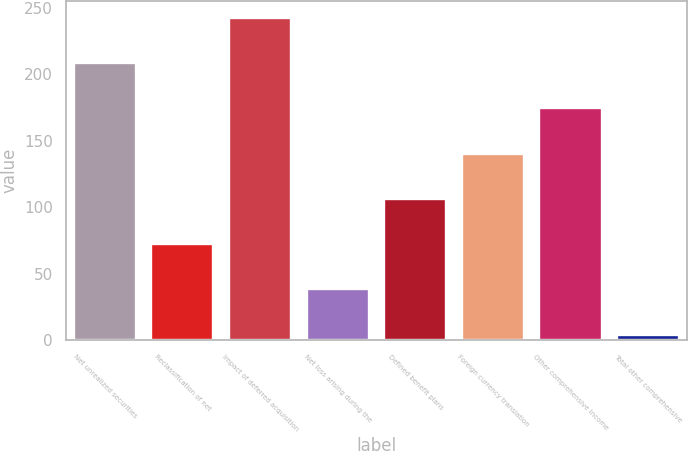Convert chart. <chart><loc_0><loc_0><loc_500><loc_500><bar_chart><fcel>Net unrealized securities<fcel>Reclassification of net<fcel>Impact of deferred acquisition<fcel>Net loss arising during the<fcel>Defined benefit plans<fcel>Foreign currency translation<fcel>Other comprehensive income<fcel>Total other comprehensive<nl><fcel>208.6<fcel>72.2<fcel>242.7<fcel>38.1<fcel>106.3<fcel>140.4<fcel>174.5<fcel>4<nl></chart> 